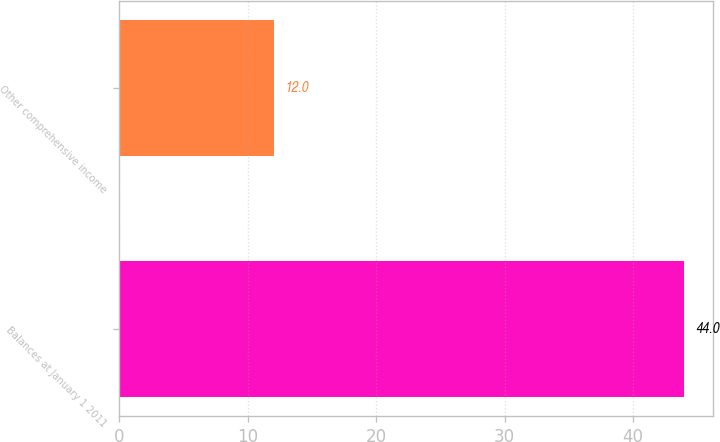<chart> <loc_0><loc_0><loc_500><loc_500><bar_chart><fcel>Balances at January 1 2011<fcel>Other comprehensive income<nl><fcel>44<fcel>12<nl></chart> 